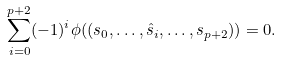Convert formula to latex. <formula><loc_0><loc_0><loc_500><loc_500>\sum _ { i = 0 } ^ { p + 2 } ( - 1 ) ^ { i } \phi ( ( s _ { 0 } , \dots , \hat { s } _ { i } , \dots , s _ { p + 2 } ) ) = 0 .</formula> 